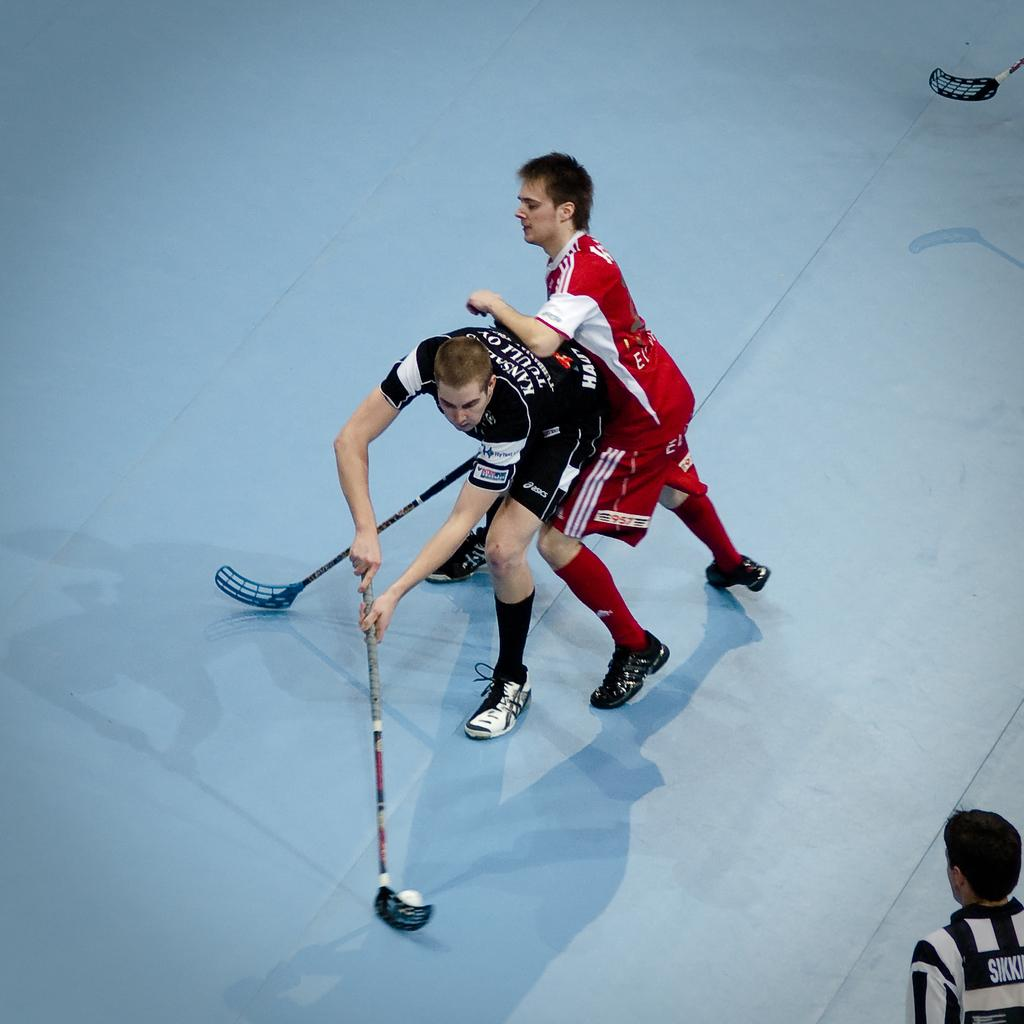What are the two men in the foreground of the image doing? The two men are playing floor ball in the foreground of the image. Where are the men playing floor ball located? The men are on the floor. Can you describe the man in the bottom right corner of the image? There is a man in the bottom right corner of the image, but no specific details about him are provided. What equipment is visible in the top part of the image? There is a bat visible in the top part of the image. What is the title of the story being acted out by the men in the image? There is no story or actor present in the image; it simply shows two men playing floor ball. 